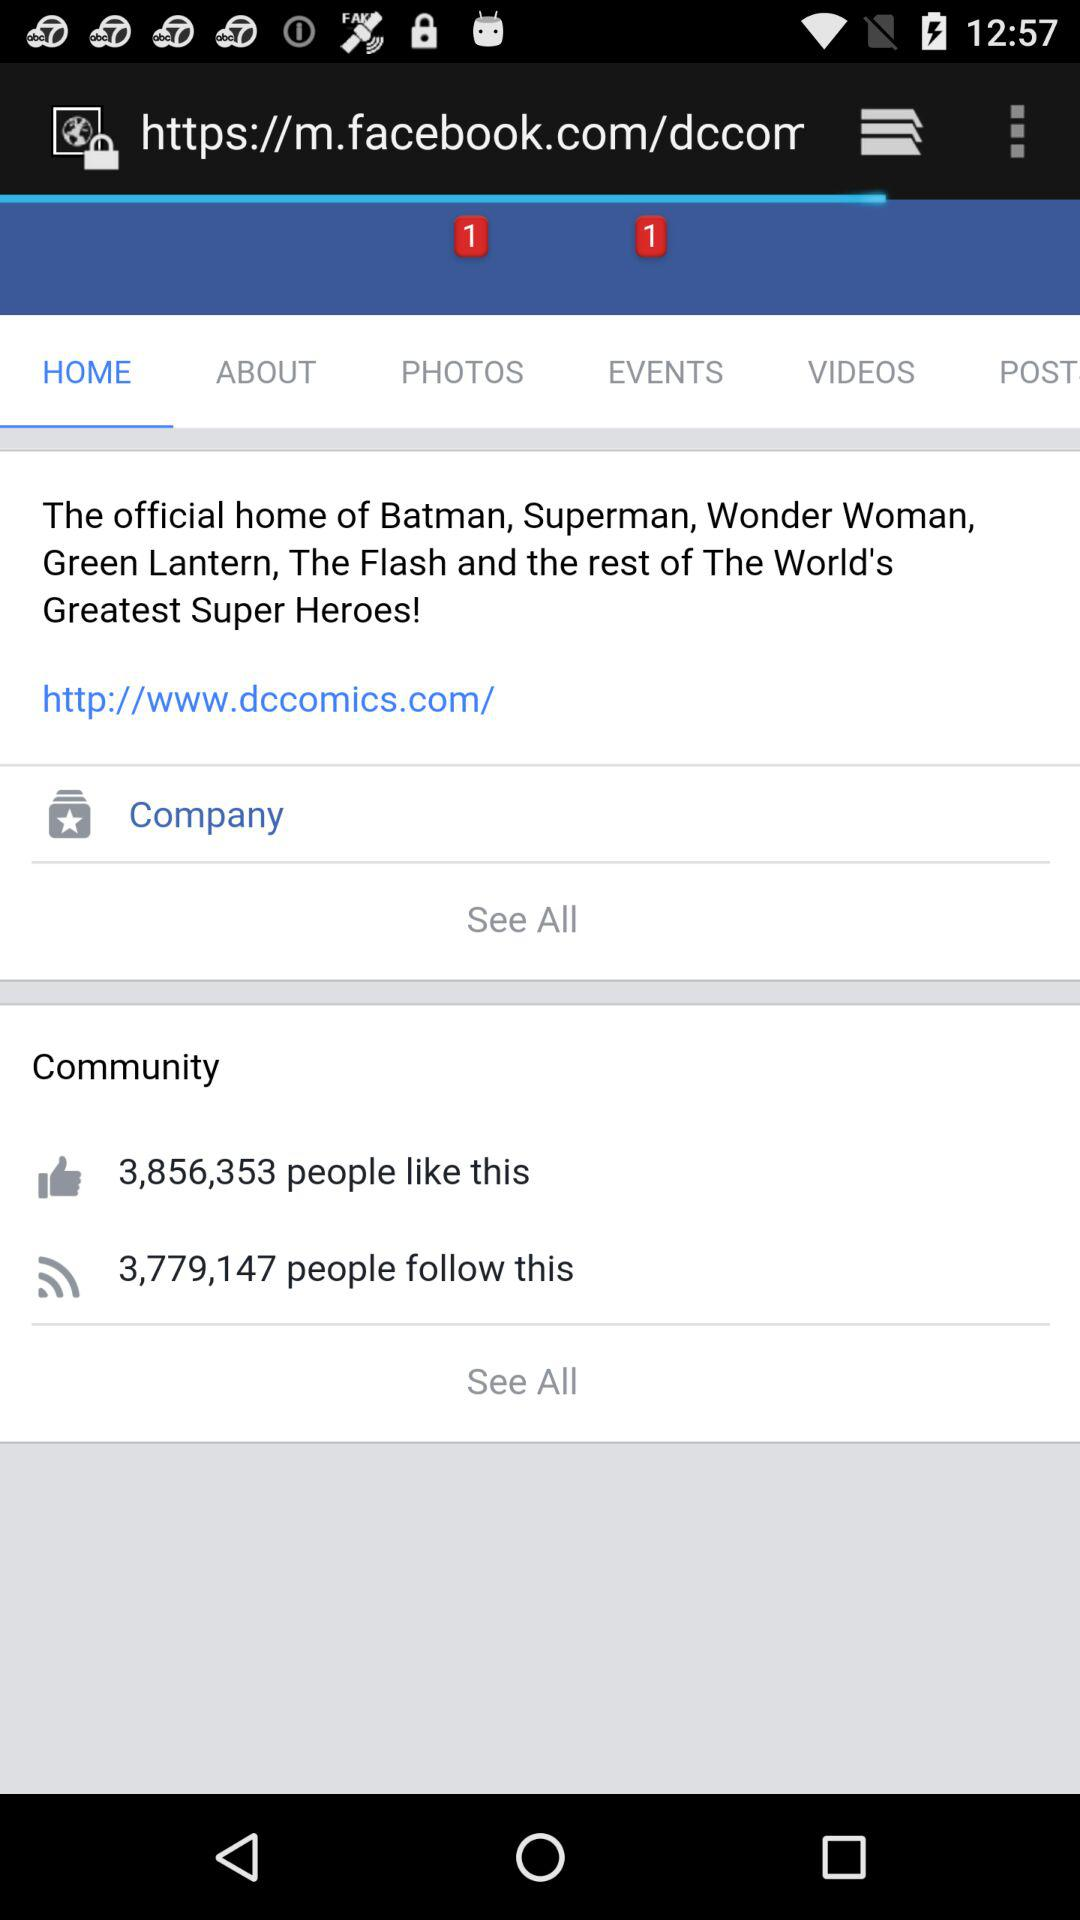How many people follow this? There are 3,779,147 people who follow this. 